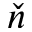Convert formula to latex. <formula><loc_0><loc_0><loc_500><loc_500>\check { n }</formula> 